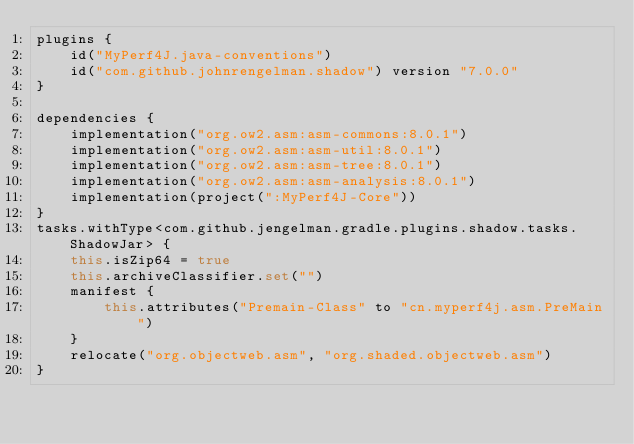<code> <loc_0><loc_0><loc_500><loc_500><_Kotlin_>plugins {
    id("MyPerf4J.java-conventions")
    id("com.github.johnrengelman.shadow") version "7.0.0"
}

dependencies {
    implementation("org.ow2.asm:asm-commons:8.0.1")
    implementation("org.ow2.asm:asm-util:8.0.1")
    implementation("org.ow2.asm:asm-tree:8.0.1")
    implementation("org.ow2.asm:asm-analysis:8.0.1")
    implementation(project(":MyPerf4J-Core"))
}
tasks.withType<com.github.jengelman.gradle.plugins.shadow.tasks.ShadowJar> {
    this.isZip64 = true
    this.archiveClassifier.set("")
    manifest {
        this.attributes("Premain-Class" to "cn.myperf4j.asm.PreMain")
    }
    relocate("org.objectweb.asm", "org.shaded.objectweb.asm")
}
</code> 